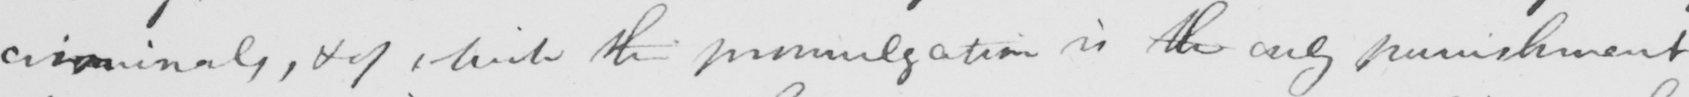Can you read and transcribe this handwriting? criminals , & of which the promulgation is the only punishment 